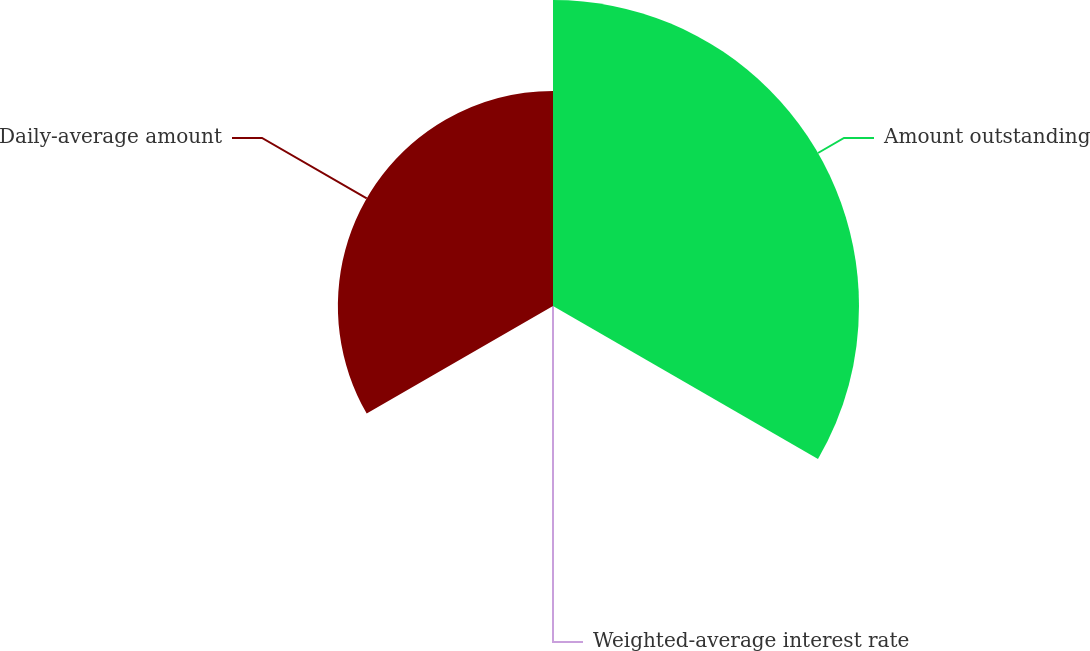Convert chart. <chart><loc_0><loc_0><loc_500><loc_500><pie_chart><fcel>Amount outstanding<fcel>Weighted-average interest rate<fcel>Daily-average amount<nl><fcel>58.72%<fcel>0.0%<fcel>41.28%<nl></chart> 